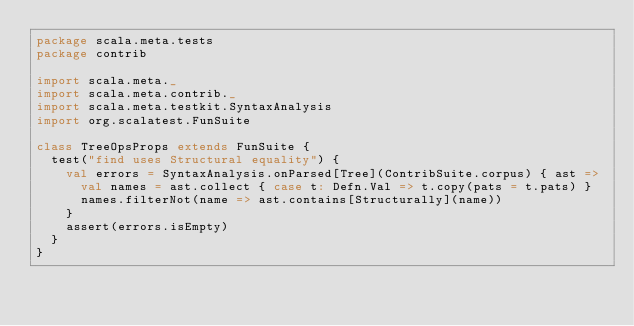Convert code to text. <code><loc_0><loc_0><loc_500><loc_500><_Scala_>package scala.meta.tests
package contrib

import scala.meta._
import scala.meta.contrib._
import scala.meta.testkit.SyntaxAnalysis
import org.scalatest.FunSuite

class TreeOpsProps extends FunSuite {
  test("find uses Structural equality") {
    val errors = SyntaxAnalysis.onParsed[Tree](ContribSuite.corpus) { ast =>
      val names = ast.collect { case t: Defn.Val => t.copy(pats = t.pats) }
      names.filterNot(name => ast.contains[Structurally](name))
    }
    assert(errors.isEmpty)
  }
}
</code> 